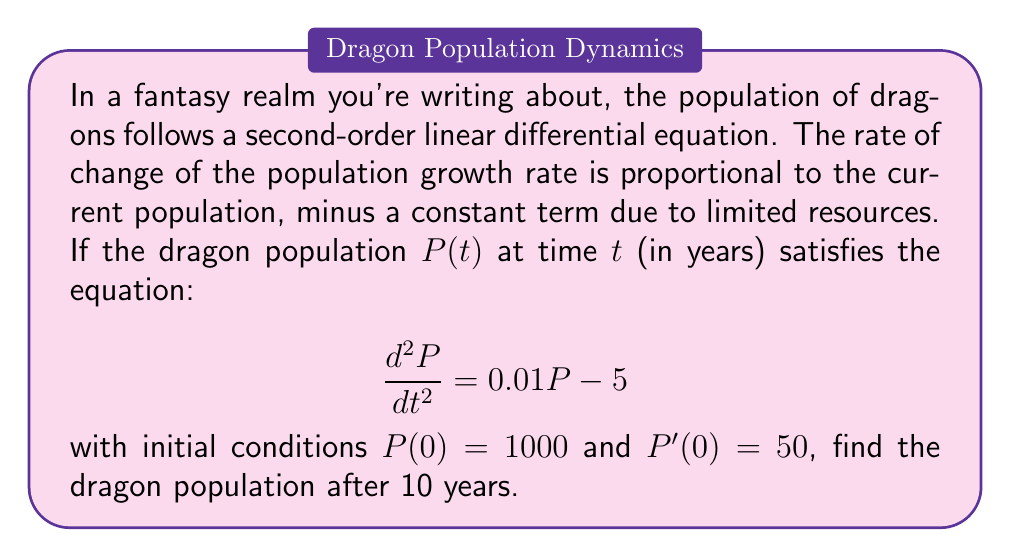What is the answer to this math problem? To solve this problem, we need to follow these steps:

1) The general solution to this second-order linear differential equation is of the form:

   $$P(t) = c_1e^{r_1t} + c_2e^{r_2t} + 500$$

   where $r_1$ and $r_2$ are the roots of the characteristic equation $r^2 = 0.01$.

2) Solving the characteristic equation:
   
   $$r^2 = 0.01$$
   $$r = \pm \sqrt{0.01} = \pm 0.1$$

3) Therefore, the general solution is:

   $$P(t) = c_1e^{0.1t} + c_2e^{-0.1t} + 500$$

4) To find $c_1$ and $c_2$, we use the initial conditions:

   $$P(0) = 1000 = c_1 + c_2 + 500$$
   $$P'(0) = 50 = 0.1c_1 - 0.1c_2$$

5) From the first equation:
   
   $$c_1 + c_2 = 500$$

6) From the second equation:

   $$c_1 - c_2 = 500$$

7) Solving these simultaneously:

   $$c_1 = 500, c_2 = 0$$

8) Therefore, the particular solution is:

   $$P(t) = 500e^{0.1t} + 500$$

9) To find the population after 10 years, we calculate $P(10)$:

   $$P(10) = 500e^{0.1(10)} + 500$$
   $$= 500e^1 + 500$$
   $$= 500(e + 1)$$
   $$\approx 1859.14$$
Answer: The dragon population after 10 years will be approximately 1859 dragons. 